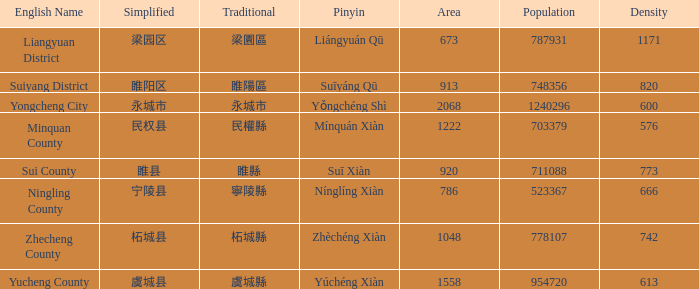How many zones have a population of 703379? 1.0. 